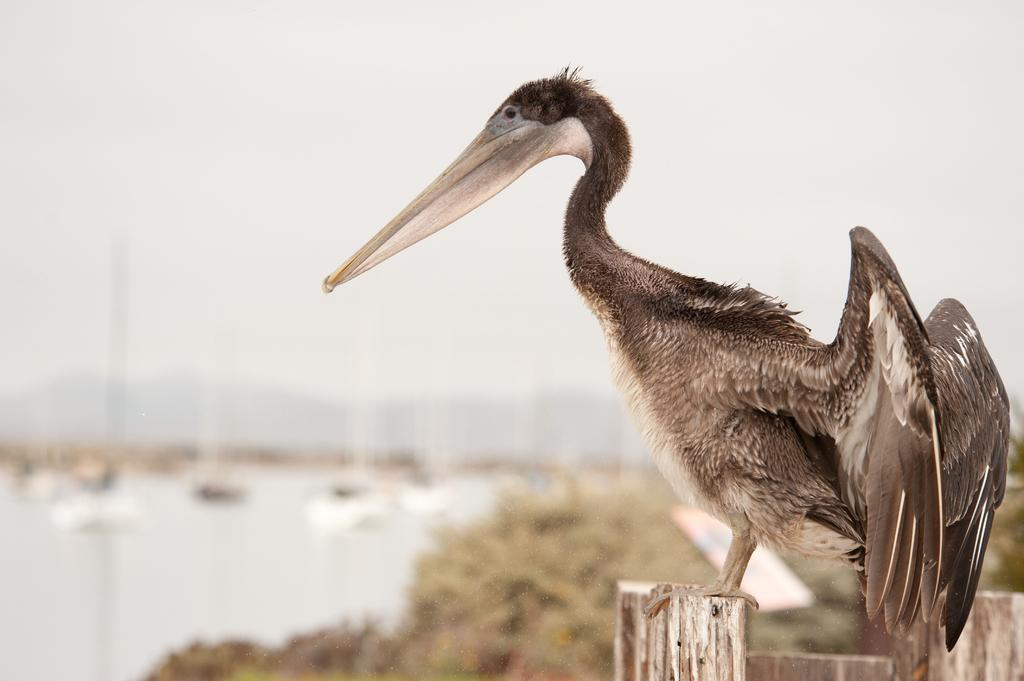What type of animal can be seen in the image? There is a bird in the image. Where is the bird located? The bird is on a wooden surface. What can be seen in the background of the image? There is a group of trees and water visible in the background. How is the background of the image depicted? The background of the image is blurred. How many cats are using the brush to paint a star in the image? There are no cats or brushes present in the image, and therefore no such activity can be observed. 